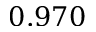<formula> <loc_0><loc_0><loc_500><loc_500>0 . 9 7 0</formula> 